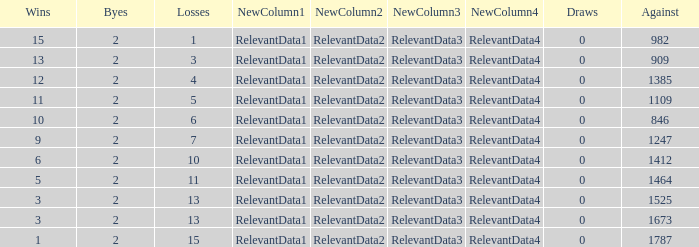What is the number listed under against when there were less than 13 losses and less than 2 byes? 0.0. 